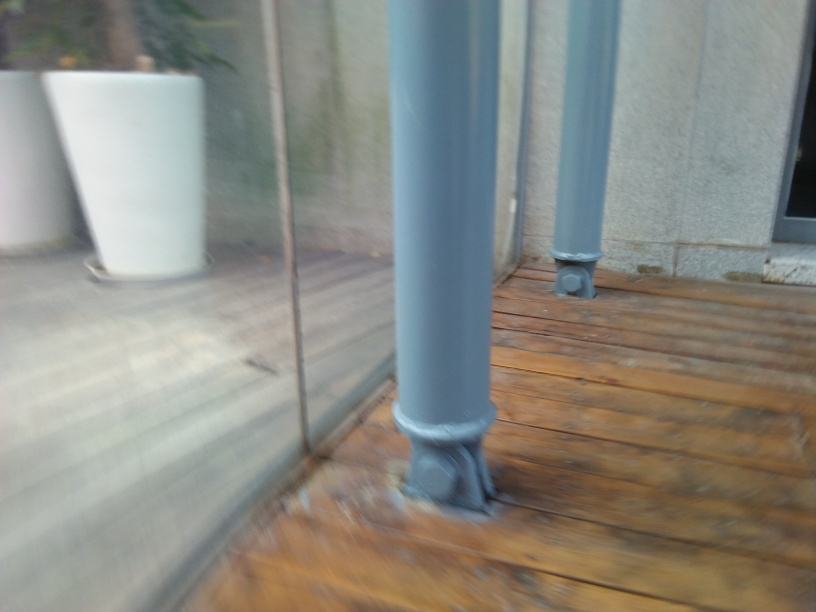Is the ground sharp and clear?
A. No
B. Yes
Answer with the option's letter from the given choices directly.
 A. 